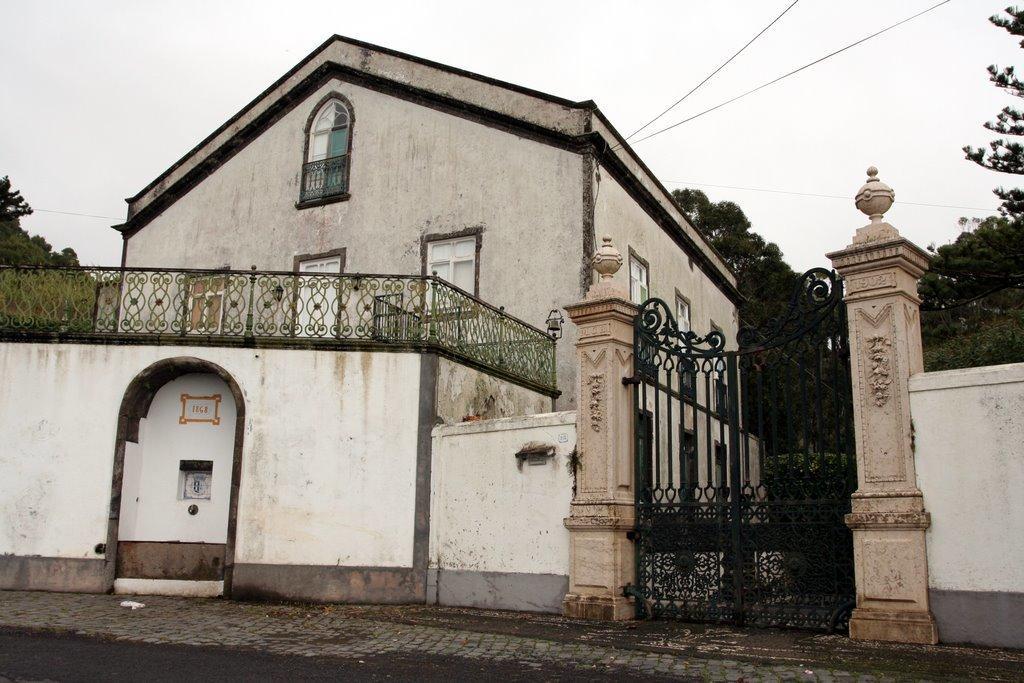Could you give a brief overview of what you see in this image? This is the building with black colour gate in order to enter into it and building is surrounded with trees on the left and right side. 